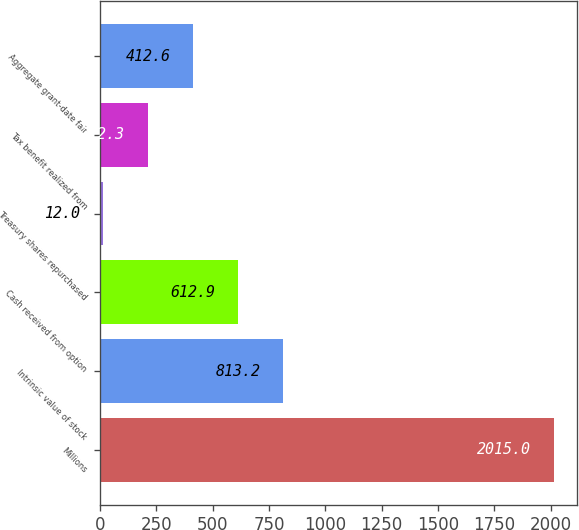Convert chart to OTSL. <chart><loc_0><loc_0><loc_500><loc_500><bar_chart><fcel>Millions<fcel>Intrinsic value of stock<fcel>Cash received from option<fcel>Treasury shares repurchased<fcel>Tax benefit realized from<fcel>Aggregate grant-date fair<nl><fcel>2015<fcel>813.2<fcel>612.9<fcel>12<fcel>212.3<fcel>412.6<nl></chart> 